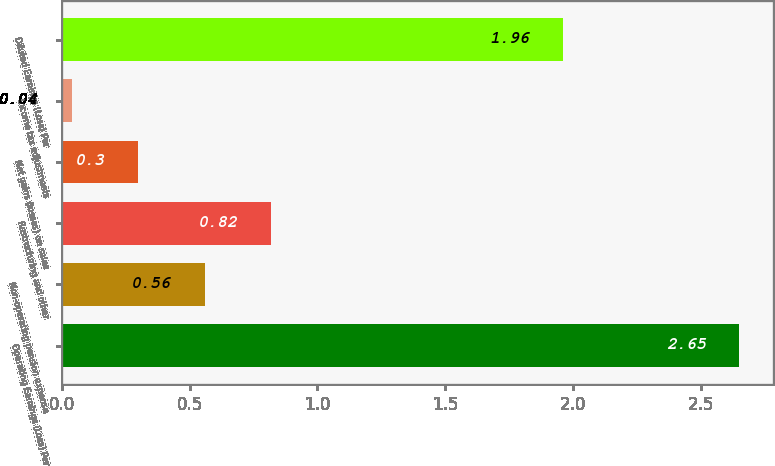Convert chart to OTSL. <chart><loc_0><loc_0><loc_500><loc_500><bar_chart><fcel>Operating Earnings (Loss) Per<fcel>Non-operating pension expense<fcel>Restructuring and other<fcel>Net gains (losses) on sales<fcel>Income tax adjustments<fcel>Diluted Earnings (Loss) Per<nl><fcel>2.65<fcel>0.56<fcel>0.82<fcel>0.3<fcel>0.04<fcel>1.96<nl></chart> 